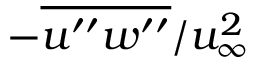Convert formula to latex. <formula><loc_0><loc_0><loc_500><loc_500>- \overline { { u ^ { \prime \prime } w ^ { \prime \prime } } } / u _ { \infty } ^ { 2 }</formula> 